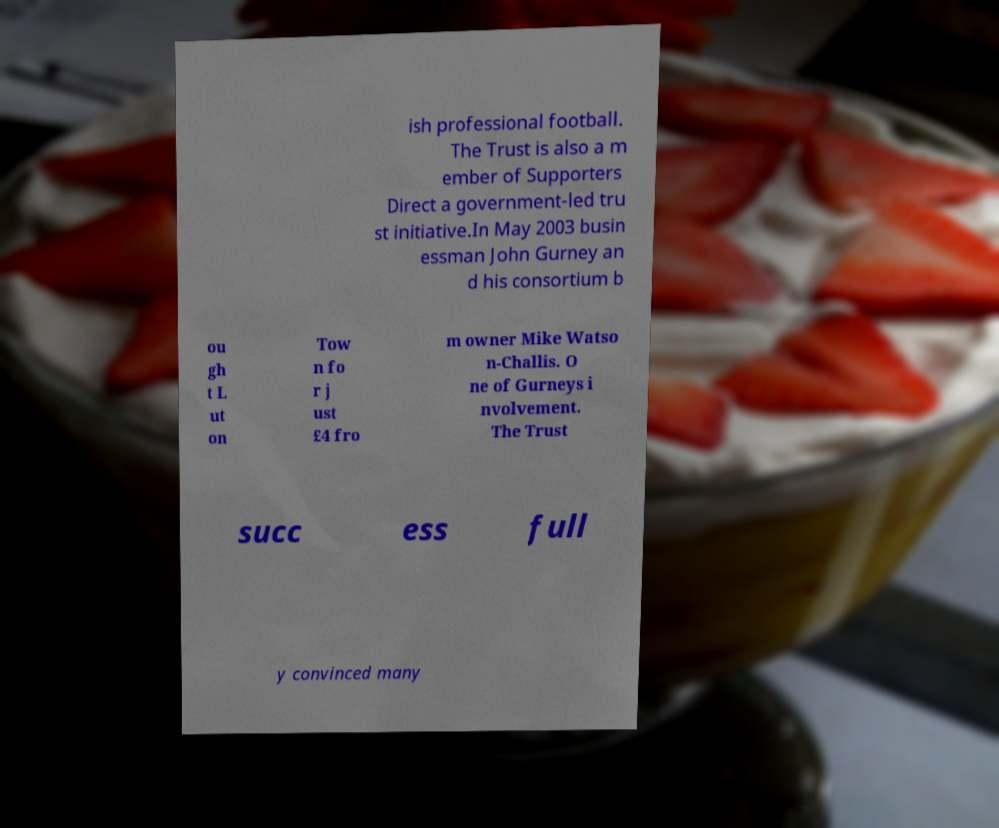Please read and relay the text visible in this image. What does it say? ish professional football. The Trust is also a m ember of Supporters Direct a government-led tru st initiative.In May 2003 busin essman John Gurney an d his consortium b ou gh t L ut on Tow n fo r j ust £4 fro m owner Mike Watso n-Challis. O ne of Gurneys i nvolvement. The Trust succ ess full y convinced many 